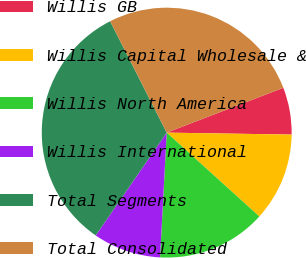Convert chart. <chart><loc_0><loc_0><loc_500><loc_500><pie_chart><fcel>Willis GB<fcel>Willis Capital Wholesale &<fcel>Willis North America<fcel>Willis International<fcel>Total Segments<fcel>Total Consolidated<nl><fcel>6.09%<fcel>11.46%<fcel>14.14%<fcel>8.77%<fcel>32.9%<fcel>26.64%<nl></chart> 